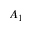<formula> <loc_0><loc_0><loc_500><loc_500>A _ { 1 }</formula> 